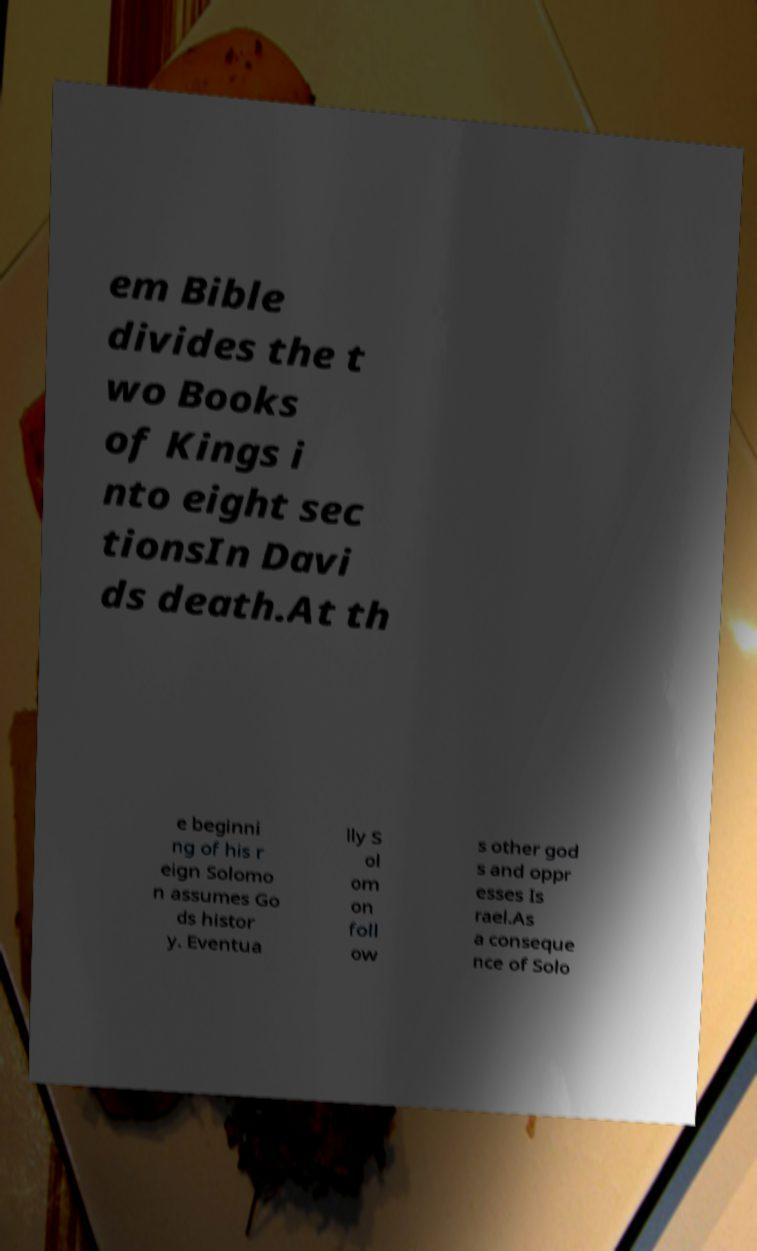For documentation purposes, I need the text within this image transcribed. Could you provide that? em Bible divides the t wo Books of Kings i nto eight sec tionsIn Davi ds death.At th e beginni ng of his r eign Solomo n assumes Go ds histor y. Eventua lly S ol om on foll ow s other god s and oppr esses Is rael.As a conseque nce of Solo 